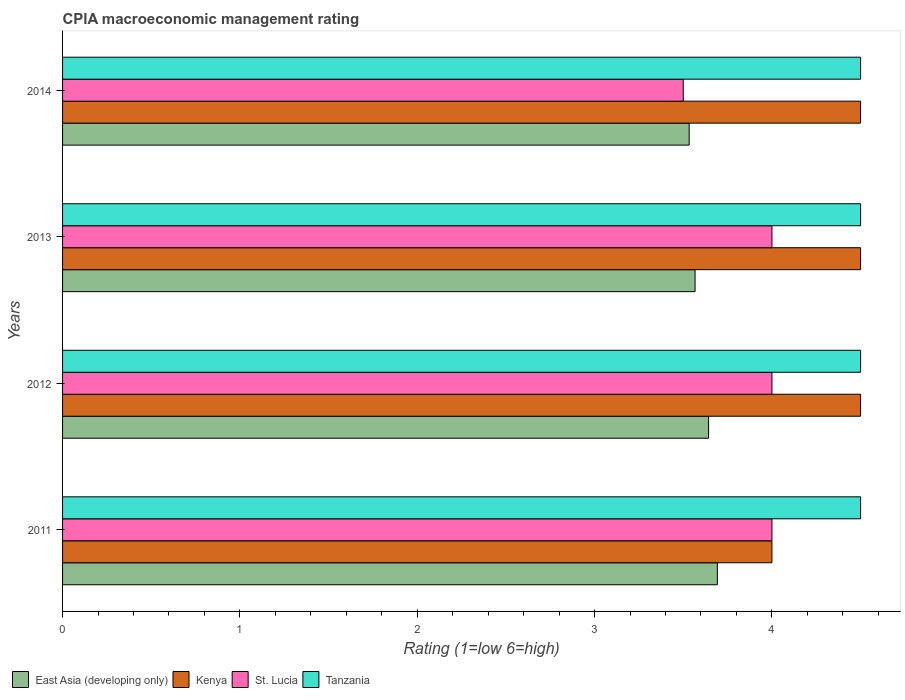How many bars are there on the 3rd tick from the top?
Your answer should be very brief. 4. How many bars are there on the 3rd tick from the bottom?
Give a very brief answer. 4. What is the CPIA rating in East Asia (developing only) in 2011?
Offer a terse response. 3.69. Across all years, what is the minimum CPIA rating in Tanzania?
Keep it short and to the point. 4.5. In which year was the CPIA rating in East Asia (developing only) minimum?
Your answer should be compact. 2014. What is the total CPIA rating in Tanzania in the graph?
Offer a very short reply. 18. What is the difference between the CPIA rating in East Asia (developing only) in 2014 and the CPIA rating in Tanzania in 2012?
Ensure brevity in your answer.  -0.97. What is the average CPIA rating in Kenya per year?
Your answer should be very brief. 4.38. In the year 2013, what is the difference between the CPIA rating in St. Lucia and CPIA rating in East Asia (developing only)?
Your answer should be very brief. 0.43. What is the ratio of the CPIA rating in Kenya in 2013 to that in 2014?
Provide a succinct answer. 1. Is the CPIA rating in East Asia (developing only) in 2012 less than that in 2014?
Your answer should be very brief. No. Is the difference between the CPIA rating in St. Lucia in 2011 and 2014 greater than the difference between the CPIA rating in East Asia (developing only) in 2011 and 2014?
Your answer should be very brief. Yes. What is the difference between the highest and the second highest CPIA rating in Tanzania?
Keep it short and to the point. 0. What does the 4th bar from the top in 2013 represents?
Your answer should be compact. East Asia (developing only). What does the 4th bar from the bottom in 2011 represents?
Provide a short and direct response. Tanzania. How many years are there in the graph?
Ensure brevity in your answer.  4. What is the difference between two consecutive major ticks on the X-axis?
Make the answer very short. 1. Where does the legend appear in the graph?
Your response must be concise. Bottom left. How are the legend labels stacked?
Give a very brief answer. Horizontal. What is the title of the graph?
Provide a succinct answer. CPIA macroeconomic management rating. Does "Tonga" appear as one of the legend labels in the graph?
Make the answer very short. No. What is the label or title of the X-axis?
Provide a succinct answer. Rating (1=low 6=high). What is the Rating (1=low 6=high) in East Asia (developing only) in 2011?
Your answer should be compact. 3.69. What is the Rating (1=low 6=high) of Kenya in 2011?
Provide a succinct answer. 4. What is the Rating (1=low 6=high) in Tanzania in 2011?
Ensure brevity in your answer.  4.5. What is the Rating (1=low 6=high) in East Asia (developing only) in 2012?
Ensure brevity in your answer.  3.64. What is the Rating (1=low 6=high) of East Asia (developing only) in 2013?
Your response must be concise. 3.57. What is the Rating (1=low 6=high) of Kenya in 2013?
Provide a succinct answer. 4.5. What is the Rating (1=low 6=high) in East Asia (developing only) in 2014?
Make the answer very short. 3.53. What is the Rating (1=low 6=high) of St. Lucia in 2014?
Provide a succinct answer. 3.5. What is the Rating (1=low 6=high) of Tanzania in 2014?
Offer a terse response. 4.5. Across all years, what is the maximum Rating (1=low 6=high) in East Asia (developing only)?
Provide a succinct answer. 3.69. Across all years, what is the maximum Rating (1=low 6=high) in St. Lucia?
Your response must be concise. 4. Across all years, what is the minimum Rating (1=low 6=high) of East Asia (developing only)?
Provide a succinct answer. 3.53. Across all years, what is the minimum Rating (1=low 6=high) of Tanzania?
Give a very brief answer. 4.5. What is the total Rating (1=low 6=high) in East Asia (developing only) in the graph?
Your answer should be very brief. 14.44. What is the total Rating (1=low 6=high) of St. Lucia in the graph?
Your answer should be compact. 15.5. What is the difference between the Rating (1=low 6=high) in East Asia (developing only) in 2011 and that in 2012?
Keep it short and to the point. 0.05. What is the difference between the Rating (1=low 6=high) in St. Lucia in 2011 and that in 2012?
Offer a very short reply. 0. What is the difference between the Rating (1=low 6=high) in East Asia (developing only) in 2011 and that in 2013?
Your answer should be very brief. 0.13. What is the difference between the Rating (1=low 6=high) of Kenya in 2011 and that in 2013?
Make the answer very short. -0.5. What is the difference between the Rating (1=low 6=high) in St. Lucia in 2011 and that in 2013?
Provide a succinct answer. 0. What is the difference between the Rating (1=low 6=high) of East Asia (developing only) in 2011 and that in 2014?
Your answer should be very brief. 0.16. What is the difference between the Rating (1=low 6=high) in Kenya in 2011 and that in 2014?
Your answer should be compact. -0.5. What is the difference between the Rating (1=low 6=high) of St. Lucia in 2011 and that in 2014?
Your answer should be very brief. 0.5. What is the difference between the Rating (1=low 6=high) of East Asia (developing only) in 2012 and that in 2013?
Your response must be concise. 0.08. What is the difference between the Rating (1=low 6=high) of Kenya in 2012 and that in 2013?
Your answer should be very brief. 0. What is the difference between the Rating (1=low 6=high) in East Asia (developing only) in 2012 and that in 2014?
Give a very brief answer. 0.11. What is the difference between the Rating (1=low 6=high) of Kenya in 2012 and that in 2014?
Your response must be concise. 0. What is the difference between the Rating (1=low 6=high) of St. Lucia in 2012 and that in 2014?
Provide a succinct answer. 0.5. What is the difference between the Rating (1=low 6=high) of East Asia (developing only) in 2013 and that in 2014?
Your answer should be compact. 0.03. What is the difference between the Rating (1=low 6=high) in Tanzania in 2013 and that in 2014?
Offer a very short reply. 0. What is the difference between the Rating (1=low 6=high) of East Asia (developing only) in 2011 and the Rating (1=low 6=high) of Kenya in 2012?
Offer a terse response. -0.81. What is the difference between the Rating (1=low 6=high) of East Asia (developing only) in 2011 and the Rating (1=low 6=high) of St. Lucia in 2012?
Offer a very short reply. -0.31. What is the difference between the Rating (1=low 6=high) of East Asia (developing only) in 2011 and the Rating (1=low 6=high) of Tanzania in 2012?
Provide a succinct answer. -0.81. What is the difference between the Rating (1=low 6=high) in St. Lucia in 2011 and the Rating (1=low 6=high) in Tanzania in 2012?
Make the answer very short. -0.5. What is the difference between the Rating (1=low 6=high) in East Asia (developing only) in 2011 and the Rating (1=low 6=high) in Kenya in 2013?
Your answer should be compact. -0.81. What is the difference between the Rating (1=low 6=high) of East Asia (developing only) in 2011 and the Rating (1=low 6=high) of St. Lucia in 2013?
Your answer should be very brief. -0.31. What is the difference between the Rating (1=low 6=high) of East Asia (developing only) in 2011 and the Rating (1=low 6=high) of Tanzania in 2013?
Ensure brevity in your answer.  -0.81. What is the difference between the Rating (1=low 6=high) in East Asia (developing only) in 2011 and the Rating (1=low 6=high) in Kenya in 2014?
Ensure brevity in your answer.  -0.81. What is the difference between the Rating (1=low 6=high) of East Asia (developing only) in 2011 and the Rating (1=low 6=high) of St. Lucia in 2014?
Offer a terse response. 0.19. What is the difference between the Rating (1=low 6=high) of East Asia (developing only) in 2011 and the Rating (1=low 6=high) of Tanzania in 2014?
Your answer should be compact. -0.81. What is the difference between the Rating (1=low 6=high) in Kenya in 2011 and the Rating (1=low 6=high) in St. Lucia in 2014?
Make the answer very short. 0.5. What is the difference between the Rating (1=low 6=high) in St. Lucia in 2011 and the Rating (1=low 6=high) in Tanzania in 2014?
Offer a very short reply. -0.5. What is the difference between the Rating (1=low 6=high) in East Asia (developing only) in 2012 and the Rating (1=low 6=high) in Kenya in 2013?
Your answer should be compact. -0.86. What is the difference between the Rating (1=low 6=high) in East Asia (developing only) in 2012 and the Rating (1=low 6=high) in St. Lucia in 2013?
Provide a succinct answer. -0.36. What is the difference between the Rating (1=low 6=high) of East Asia (developing only) in 2012 and the Rating (1=low 6=high) of Tanzania in 2013?
Keep it short and to the point. -0.86. What is the difference between the Rating (1=low 6=high) of Kenya in 2012 and the Rating (1=low 6=high) of St. Lucia in 2013?
Ensure brevity in your answer.  0.5. What is the difference between the Rating (1=low 6=high) of Kenya in 2012 and the Rating (1=low 6=high) of Tanzania in 2013?
Your response must be concise. 0. What is the difference between the Rating (1=low 6=high) of St. Lucia in 2012 and the Rating (1=low 6=high) of Tanzania in 2013?
Ensure brevity in your answer.  -0.5. What is the difference between the Rating (1=low 6=high) of East Asia (developing only) in 2012 and the Rating (1=low 6=high) of Kenya in 2014?
Offer a terse response. -0.86. What is the difference between the Rating (1=low 6=high) in East Asia (developing only) in 2012 and the Rating (1=low 6=high) in St. Lucia in 2014?
Give a very brief answer. 0.14. What is the difference between the Rating (1=low 6=high) of East Asia (developing only) in 2012 and the Rating (1=low 6=high) of Tanzania in 2014?
Ensure brevity in your answer.  -0.86. What is the difference between the Rating (1=low 6=high) of Kenya in 2012 and the Rating (1=low 6=high) of St. Lucia in 2014?
Your answer should be compact. 1. What is the difference between the Rating (1=low 6=high) in East Asia (developing only) in 2013 and the Rating (1=low 6=high) in Kenya in 2014?
Provide a succinct answer. -0.93. What is the difference between the Rating (1=low 6=high) of East Asia (developing only) in 2013 and the Rating (1=low 6=high) of St. Lucia in 2014?
Ensure brevity in your answer.  0.07. What is the difference between the Rating (1=low 6=high) of East Asia (developing only) in 2013 and the Rating (1=low 6=high) of Tanzania in 2014?
Your response must be concise. -0.93. What is the difference between the Rating (1=low 6=high) of Kenya in 2013 and the Rating (1=low 6=high) of St. Lucia in 2014?
Make the answer very short. 1. What is the difference between the Rating (1=low 6=high) of St. Lucia in 2013 and the Rating (1=low 6=high) of Tanzania in 2014?
Offer a very short reply. -0.5. What is the average Rating (1=low 6=high) of East Asia (developing only) per year?
Make the answer very short. 3.61. What is the average Rating (1=low 6=high) in Kenya per year?
Provide a succinct answer. 4.38. What is the average Rating (1=low 6=high) in St. Lucia per year?
Offer a terse response. 3.88. In the year 2011, what is the difference between the Rating (1=low 6=high) in East Asia (developing only) and Rating (1=low 6=high) in Kenya?
Offer a terse response. -0.31. In the year 2011, what is the difference between the Rating (1=low 6=high) of East Asia (developing only) and Rating (1=low 6=high) of St. Lucia?
Keep it short and to the point. -0.31. In the year 2011, what is the difference between the Rating (1=low 6=high) of East Asia (developing only) and Rating (1=low 6=high) of Tanzania?
Your answer should be compact. -0.81. In the year 2011, what is the difference between the Rating (1=low 6=high) of Kenya and Rating (1=low 6=high) of St. Lucia?
Your answer should be very brief. 0. In the year 2012, what is the difference between the Rating (1=low 6=high) of East Asia (developing only) and Rating (1=low 6=high) of Kenya?
Keep it short and to the point. -0.86. In the year 2012, what is the difference between the Rating (1=low 6=high) in East Asia (developing only) and Rating (1=low 6=high) in St. Lucia?
Give a very brief answer. -0.36. In the year 2012, what is the difference between the Rating (1=low 6=high) in East Asia (developing only) and Rating (1=low 6=high) in Tanzania?
Ensure brevity in your answer.  -0.86. In the year 2012, what is the difference between the Rating (1=low 6=high) in Kenya and Rating (1=low 6=high) in St. Lucia?
Your answer should be compact. 0.5. In the year 2012, what is the difference between the Rating (1=low 6=high) in Kenya and Rating (1=low 6=high) in Tanzania?
Your answer should be very brief. 0. In the year 2012, what is the difference between the Rating (1=low 6=high) of St. Lucia and Rating (1=low 6=high) of Tanzania?
Provide a short and direct response. -0.5. In the year 2013, what is the difference between the Rating (1=low 6=high) of East Asia (developing only) and Rating (1=low 6=high) of Kenya?
Ensure brevity in your answer.  -0.93. In the year 2013, what is the difference between the Rating (1=low 6=high) in East Asia (developing only) and Rating (1=low 6=high) in St. Lucia?
Offer a very short reply. -0.43. In the year 2013, what is the difference between the Rating (1=low 6=high) in East Asia (developing only) and Rating (1=low 6=high) in Tanzania?
Your answer should be compact. -0.93. In the year 2013, what is the difference between the Rating (1=low 6=high) in St. Lucia and Rating (1=low 6=high) in Tanzania?
Ensure brevity in your answer.  -0.5. In the year 2014, what is the difference between the Rating (1=low 6=high) in East Asia (developing only) and Rating (1=low 6=high) in Kenya?
Make the answer very short. -0.97. In the year 2014, what is the difference between the Rating (1=low 6=high) of East Asia (developing only) and Rating (1=low 6=high) of Tanzania?
Keep it short and to the point. -0.97. In the year 2014, what is the difference between the Rating (1=low 6=high) in Kenya and Rating (1=low 6=high) in St. Lucia?
Make the answer very short. 1. What is the ratio of the Rating (1=low 6=high) of East Asia (developing only) in 2011 to that in 2012?
Provide a succinct answer. 1.01. What is the ratio of the Rating (1=low 6=high) in Kenya in 2011 to that in 2012?
Offer a terse response. 0.89. What is the ratio of the Rating (1=low 6=high) of St. Lucia in 2011 to that in 2012?
Offer a terse response. 1. What is the ratio of the Rating (1=low 6=high) of Tanzania in 2011 to that in 2012?
Offer a terse response. 1. What is the ratio of the Rating (1=low 6=high) of East Asia (developing only) in 2011 to that in 2013?
Give a very brief answer. 1.04. What is the ratio of the Rating (1=low 6=high) in Kenya in 2011 to that in 2013?
Offer a terse response. 0.89. What is the ratio of the Rating (1=low 6=high) of St. Lucia in 2011 to that in 2013?
Ensure brevity in your answer.  1. What is the ratio of the Rating (1=low 6=high) in East Asia (developing only) in 2011 to that in 2014?
Ensure brevity in your answer.  1.04. What is the ratio of the Rating (1=low 6=high) in Kenya in 2011 to that in 2014?
Offer a very short reply. 0.89. What is the ratio of the Rating (1=low 6=high) in St. Lucia in 2011 to that in 2014?
Keep it short and to the point. 1.14. What is the ratio of the Rating (1=low 6=high) of East Asia (developing only) in 2012 to that in 2013?
Ensure brevity in your answer.  1.02. What is the ratio of the Rating (1=low 6=high) in St. Lucia in 2012 to that in 2013?
Keep it short and to the point. 1. What is the ratio of the Rating (1=low 6=high) in Tanzania in 2012 to that in 2013?
Provide a short and direct response. 1. What is the ratio of the Rating (1=low 6=high) in East Asia (developing only) in 2012 to that in 2014?
Offer a terse response. 1.03. What is the ratio of the Rating (1=low 6=high) of Kenya in 2012 to that in 2014?
Ensure brevity in your answer.  1. What is the ratio of the Rating (1=low 6=high) of St. Lucia in 2012 to that in 2014?
Make the answer very short. 1.14. What is the ratio of the Rating (1=low 6=high) in East Asia (developing only) in 2013 to that in 2014?
Ensure brevity in your answer.  1.01. What is the ratio of the Rating (1=low 6=high) of Kenya in 2013 to that in 2014?
Keep it short and to the point. 1. What is the ratio of the Rating (1=low 6=high) in St. Lucia in 2013 to that in 2014?
Offer a very short reply. 1.14. What is the difference between the highest and the second highest Rating (1=low 6=high) of East Asia (developing only)?
Offer a very short reply. 0.05. What is the difference between the highest and the second highest Rating (1=low 6=high) in St. Lucia?
Your answer should be compact. 0. What is the difference between the highest and the second highest Rating (1=low 6=high) of Tanzania?
Your answer should be very brief. 0. What is the difference between the highest and the lowest Rating (1=low 6=high) in East Asia (developing only)?
Keep it short and to the point. 0.16. What is the difference between the highest and the lowest Rating (1=low 6=high) in Kenya?
Make the answer very short. 0.5. 